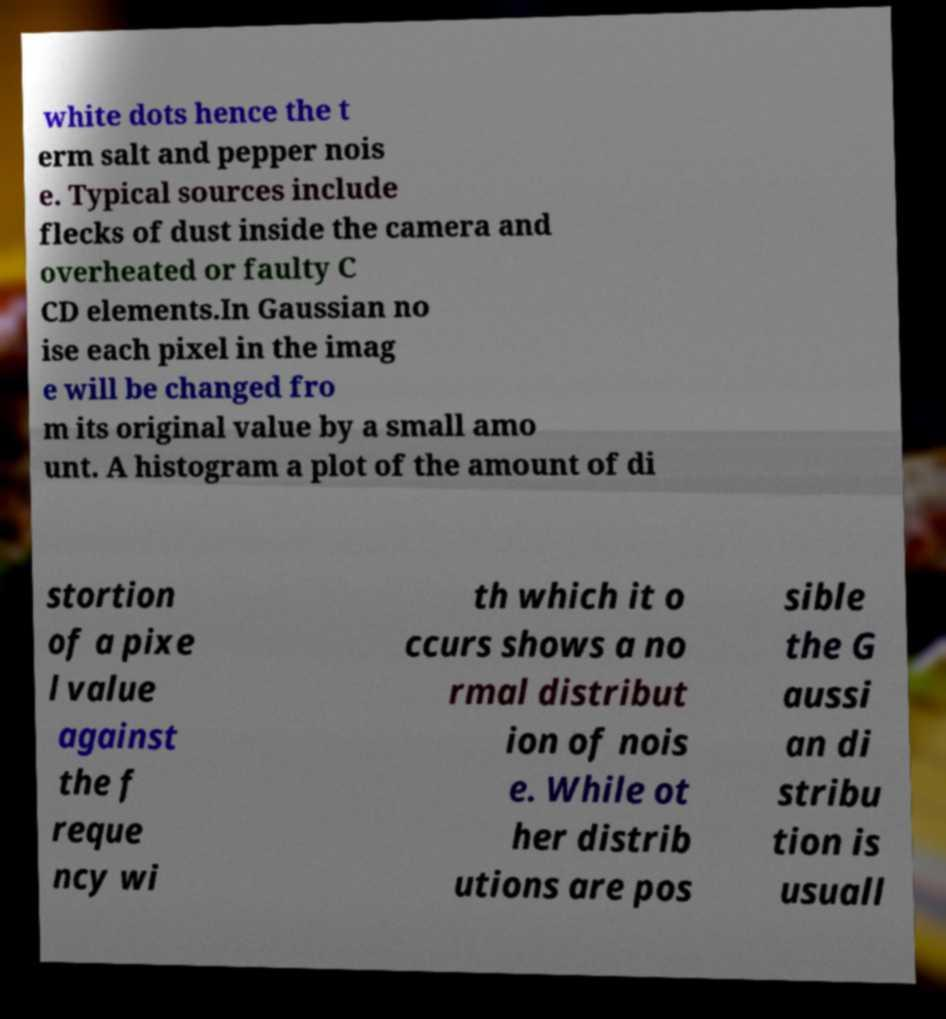I need the written content from this picture converted into text. Can you do that? white dots hence the t erm salt and pepper nois e. Typical sources include flecks of dust inside the camera and overheated or faulty C CD elements.In Gaussian no ise each pixel in the imag e will be changed fro m its original value by a small amo unt. A histogram a plot of the amount of di stortion of a pixe l value against the f reque ncy wi th which it o ccurs shows a no rmal distribut ion of nois e. While ot her distrib utions are pos sible the G aussi an di stribu tion is usuall 